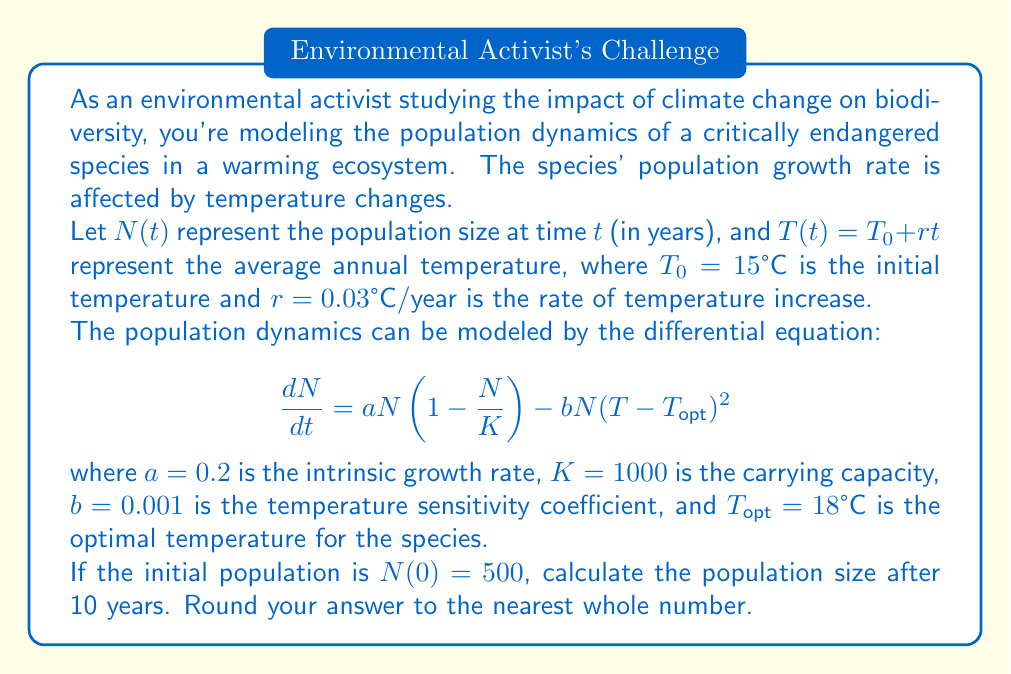Solve this math problem. To solve this problem, we'll use numerical methods, specifically the Runge-Kutta 4th order method (RK4), to approximate the solution to the differential equation.

Step 1: Define the differential equation function.
$$f(t, N) = aN(1 - \frac{N}{K}) - bN(T(t)-T_{opt})^2$$

Step 2: Implement the RK4 method.
For a step size $h$, the RK4 method is given by:
$$N_{n+1} = N_n + \frac{1}{6}(k_1 + 2k_2 + 2k_3 + k_4)$$
where:
$$\begin{align*}
k_1 &= hf(t_n, N_n) \\
k_2 &= hf(t_n + \frac{h}{2}, N_n + \frac{k_1}{2}) \\
k_3 &= hf(t_n + \frac{h}{2}, N_n + \frac{k_2}{2}) \\
k_4 &= hf(t_n + h, N_n + k_3)
\end{align*}$$

Step 3: Set up the initial conditions and parameters.
$t_0 = 0$, $N_0 = 500$, $h = 0.1$ (we'll use 100 steps for the 10-year period)

Step 4: Iterate through the RK4 method for 100 steps.
At each step, calculate $T(t) = 15 + 0.03t$ and use it in the function $f(t, N)$.

Step 5: After 100 iterations, we get the final population size.

Using a computer program to perform these calculations, we get:

$N(10) \approx 614.7$

Rounding to the nearest whole number, we get 615.
Answer: 615 